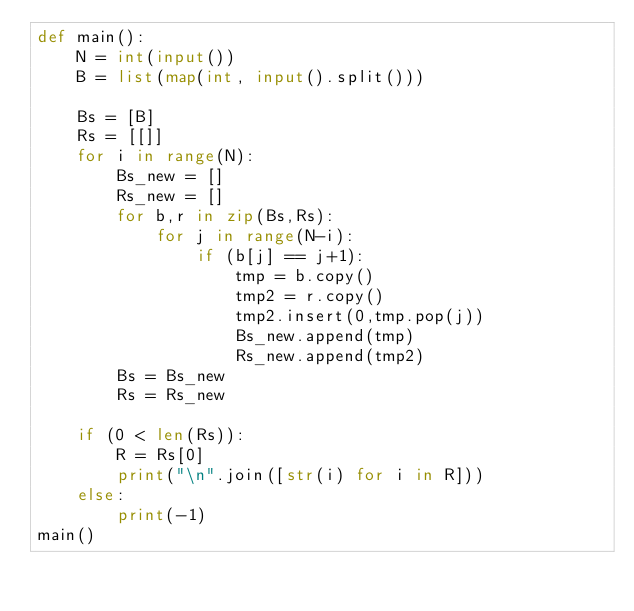<code> <loc_0><loc_0><loc_500><loc_500><_Python_>def main():
    N = int(input())
    B = list(map(int, input().split()))
    
    Bs = [B]
    Rs = [[]]
    for i in range(N):
        Bs_new = []
        Rs_new = []
        for b,r in zip(Bs,Rs):
            for j in range(N-i):
                if (b[j] == j+1):
                    tmp = b.copy()
                    tmp2 = r.copy()
                    tmp2.insert(0,tmp.pop(j))
                    Bs_new.append(tmp)
                    Rs_new.append(tmp2)
        Bs = Bs_new
        Rs = Rs_new
    
    if (0 < len(Rs)):
        R = Rs[0]
        print("\n".join([str(i) for i in R]))
    else:
        print(-1)
main()
</code> 